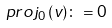<formula> <loc_0><loc_0><loc_500><loc_500>p r o j _ { 0 } \, ( v ) \colon = 0</formula> 